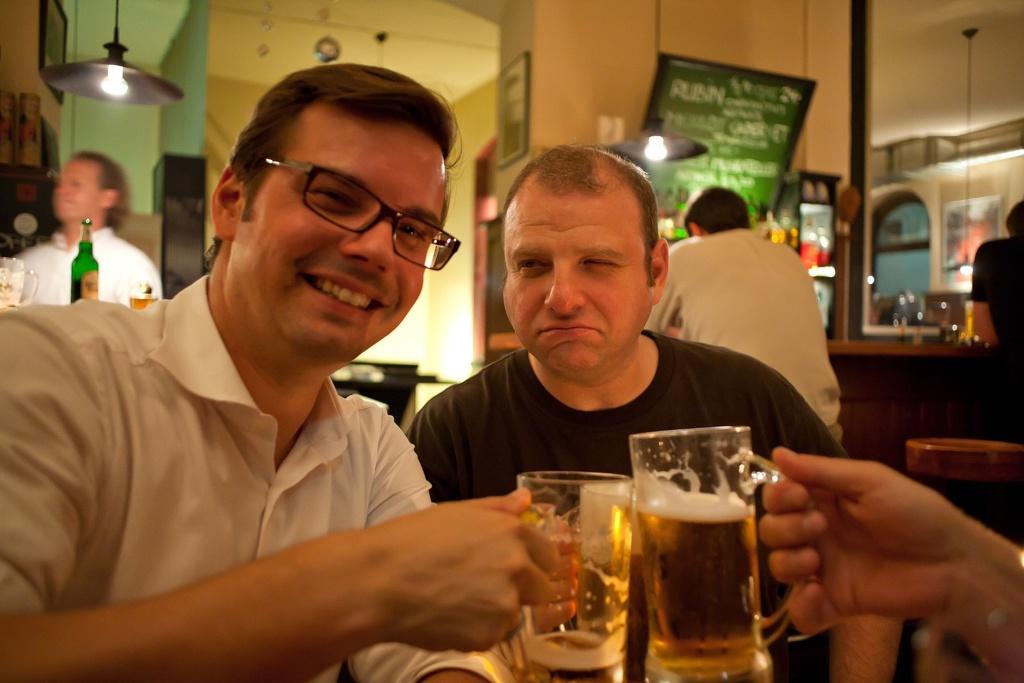Could you give a brief overview of what you see in this image? there are two persons sitting and having a drink. 